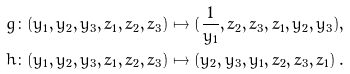<formula> <loc_0><loc_0><loc_500><loc_500>g \colon ( y _ { 1 } , y _ { 2 } , y _ { 3 } , z _ { 1 } , z _ { 2 } , z _ { 3 } ) & \mapsto ( \frac { 1 } { y _ { 1 } } , z _ { 2 } , z _ { 3 } , z _ { 1 } , y _ { 2 } , y _ { 3 } ) , \ \quad \\ h \colon ( y _ { 1 } , y _ { 2 } , y _ { 3 } , z _ { 1 } , z _ { 2 } , z _ { 3 } ) & \mapsto ( y _ { 2 } , y _ { 3 } , y _ { 1 } , z _ { 2 } , z _ { 3 } , z _ { 1 } ) \, .</formula> 